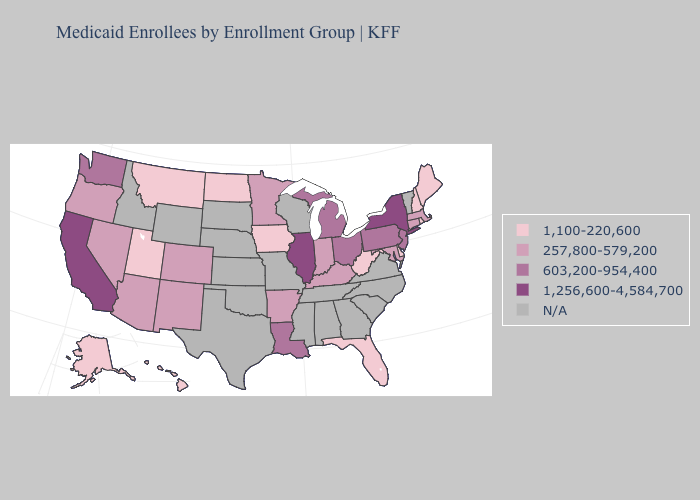Does Delaware have the lowest value in the USA?
Be succinct. Yes. Name the states that have a value in the range 1,256,600-4,584,700?
Be succinct. California, Illinois, New York. Does New Hampshire have the lowest value in the USA?
Write a very short answer. Yes. Name the states that have a value in the range 257,800-579,200?
Keep it brief. Arizona, Arkansas, Colorado, Connecticut, Indiana, Kentucky, Maryland, Massachusetts, Minnesota, Nevada, New Mexico, Oregon. What is the highest value in the USA?
Short answer required. 1,256,600-4,584,700. Name the states that have a value in the range 257,800-579,200?
Be succinct. Arizona, Arkansas, Colorado, Connecticut, Indiana, Kentucky, Maryland, Massachusetts, Minnesota, Nevada, New Mexico, Oregon. What is the value of California?
Be succinct. 1,256,600-4,584,700. Does the map have missing data?
Short answer required. Yes. Name the states that have a value in the range 603,200-954,400?
Give a very brief answer. Louisiana, Michigan, New Jersey, Ohio, Pennsylvania, Washington. What is the lowest value in the MidWest?
Keep it brief. 1,100-220,600. What is the highest value in the Northeast ?
Be succinct. 1,256,600-4,584,700. 